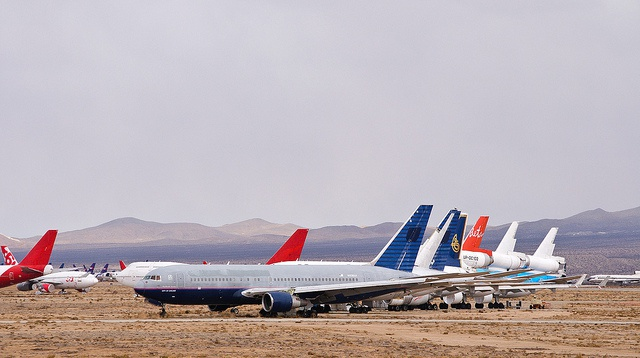Describe the objects in this image and their specific colors. I can see airplane in lightgray, black, and darkgray tones, airplane in lightgray, darkgray, gray, and black tones, airplane in lightgray, brown, and maroon tones, airplane in lightgray, brown, and darkgray tones, and airplane in lightgray, darkgray, and gray tones in this image. 